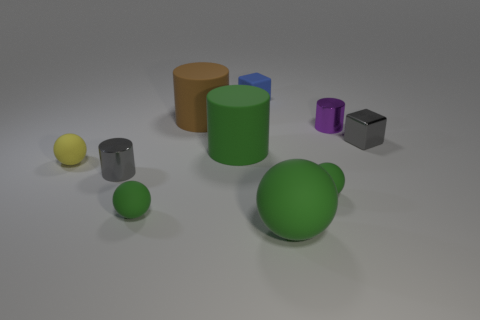Subtract all large matte spheres. How many spheres are left? 3 Subtract all gray cylinders. How many cylinders are left? 3 Subtract all cubes. How many objects are left? 8 Subtract 2 cylinders. How many cylinders are left? 2 Subtract all red spheres. How many purple cylinders are left? 1 Subtract all small green matte balls. Subtract all balls. How many objects are left? 4 Add 4 tiny gray shiny cylinders. How many tiny gray shiny cylinders are left? 5 Add 3 small green matte balls. How many small green matte balls exist? 5 Subtract 0 purple balls. How many objects are left? 10 Subtract all red cylinders. Subtract all green blocks. How many cylinders are left? 4 